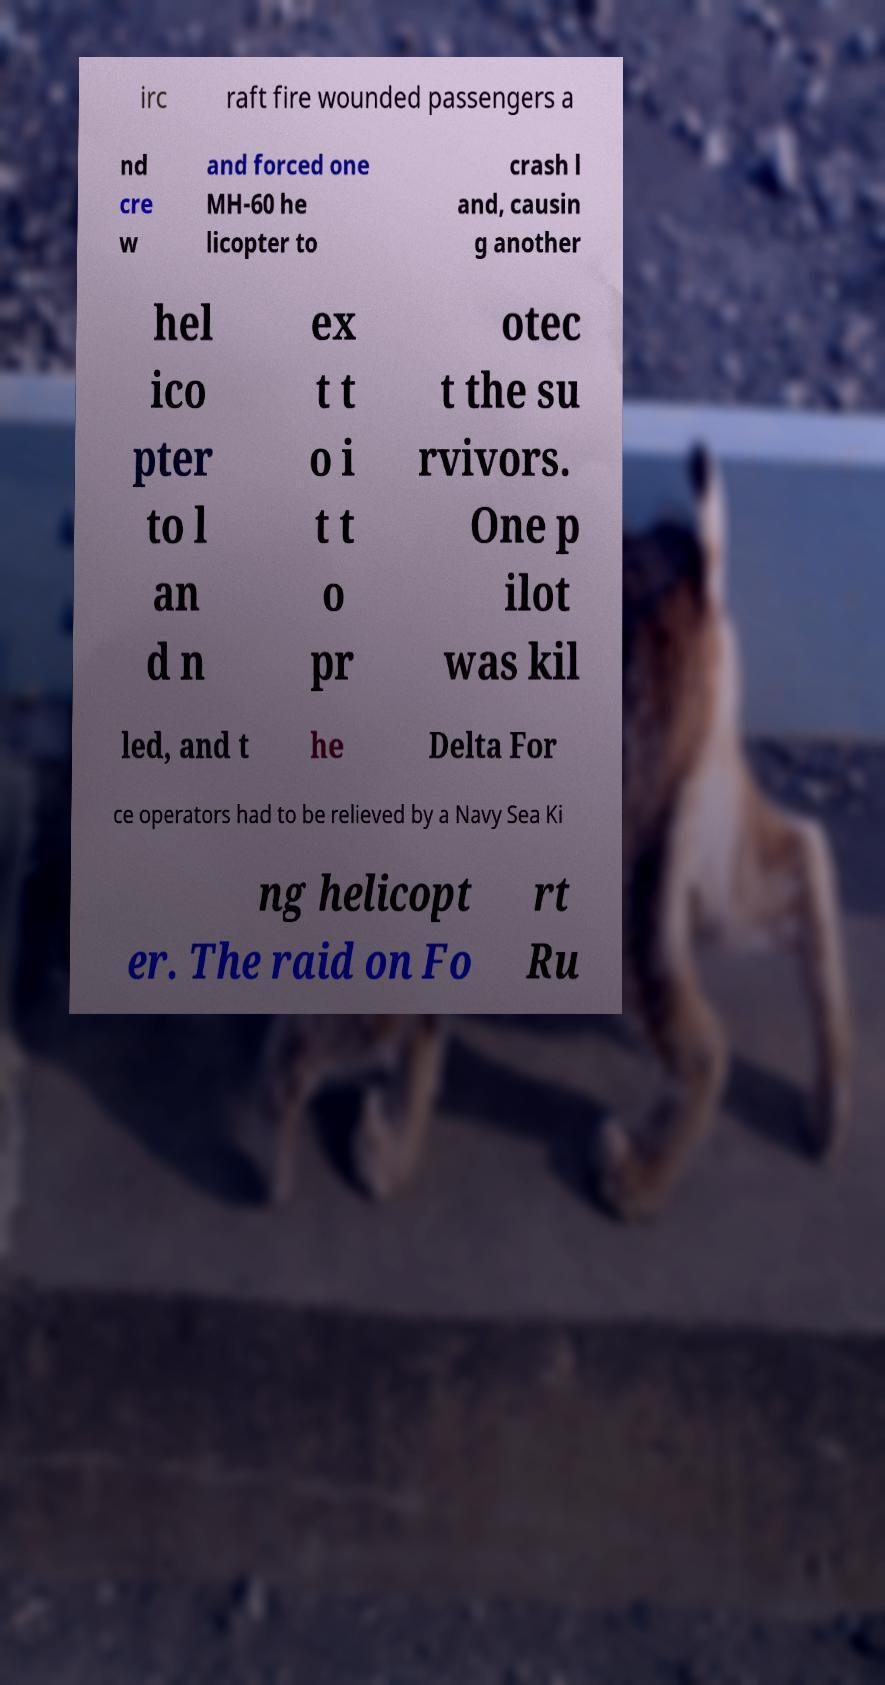Can you accurately transcribe the text from the provided image for me? irc raft fire wounded passengers a nd cre w and forced one MH-60 he licopter to crash l and, causin g another hel ico pter to l an d n ex t t o i t t o pr otec t the su rvivors. One p ilot was kil led, and t he Delta For ce operators had to be relieved by a Navy Sea Ki ng helicopt er. The raid on Fo rt Ru 